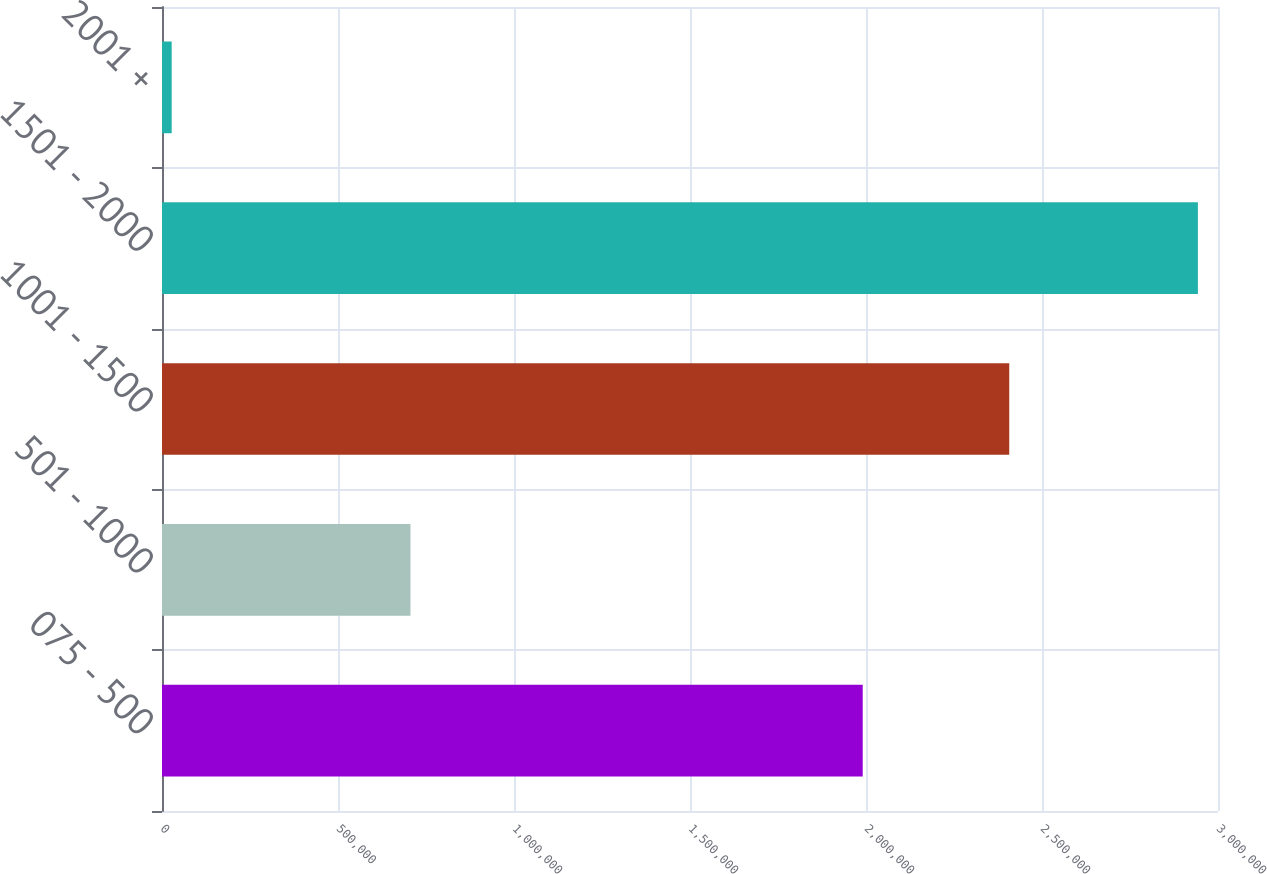Convert chart. <chart><loc_0><loc_0><loc_500><loc_500><bar_chart><fcel>075 - 500<fcel>501 - 1000<fcel>1001 - 1500<fcel>1501 - 2000<fcel>2001 +<nl><fcel>1.99065e+06<fcel>705945<fcel>2.40695e+06<fcel>2.94292e+06<fcel>27500<nl></chart> 